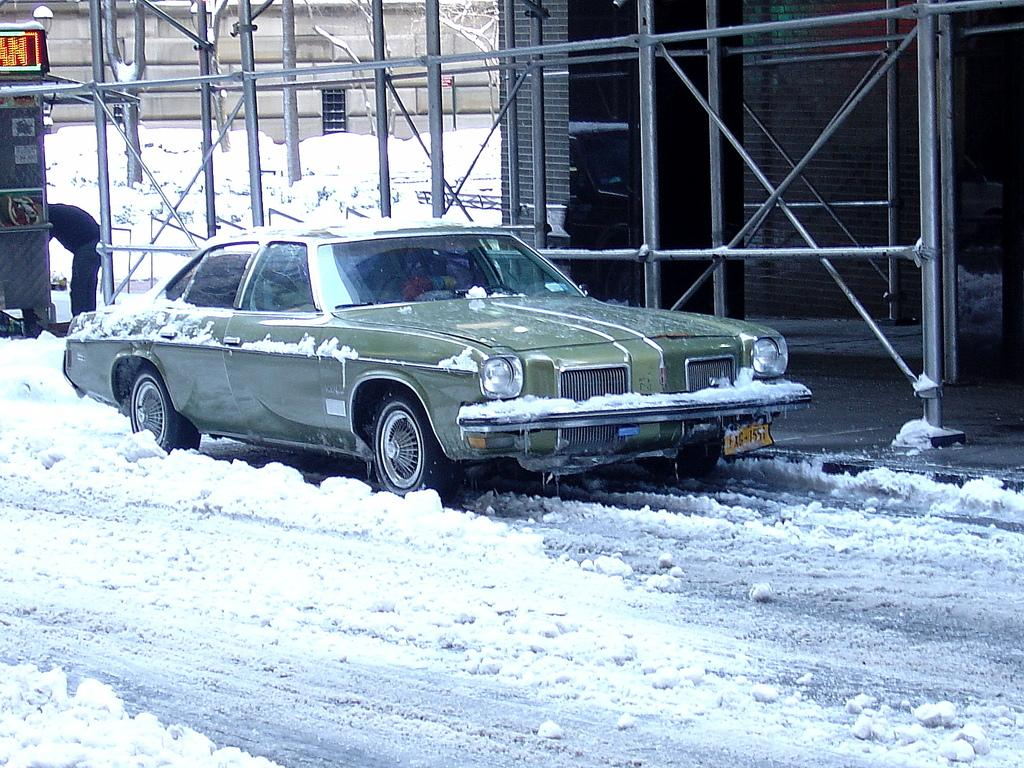What is the primary feature of the landscape in the image? There is snow in the image. What type of vehicle can be seen on the road in the image? There is a car on the road in the image. Can you describe the background of the image? In the background of the image, there is a person, poles, walls, trees, and some objects. What type of jeans is the person wearing in the image? There is no person wearing jeans in the image; the person in the background is not described in enough detail to determine their clothing. 